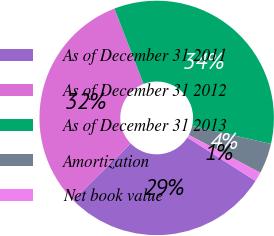Convert chart to OTSL. <chart><loc_0><loc_0><loc_500><loc_500><pie_chart><fcel>As of December 31 2011<fcel>As of December 31 2012<fcel>As of December 31 2013<fcel>Amortization<fcel>Net book value<nl><fcel>28.6%<fcel>31.51%<fcel>34.42%<fcel>4.19%<fcel>1.28%<nl></chart> 